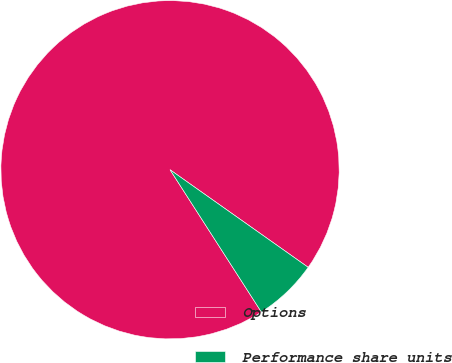Convert chart. <chart><loc_0><loc_0><loc_500><loc_500><pie_chart><fcel>Options<fcel>Performance share units<nl><fcel>93.87%<fcel>6.13%<nl></chart> 